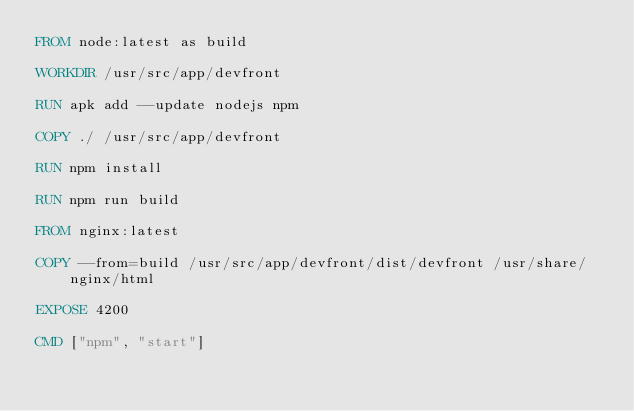Convert code to text. <code><loc_0><loc_0><loc_500><loc_500><_Dockerfile_>FROM node:latest as build

WORKDIR /usr/src/app/devfront

RUN apk add --update nodejs npm

COPY ./ /usr/src/app/devfront

RUN npm install

RUN npm run build

FROM nginx:latest

COPY --from=build /usr/src/app/devfront/dist/devfront /usr/share/nginx/html

EXPOSE 4200

CMD ["npm", "start"]</code> 